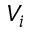<formula> <loc_0><loc_0><loc_500><loc_500>V _ { i }</formula> 